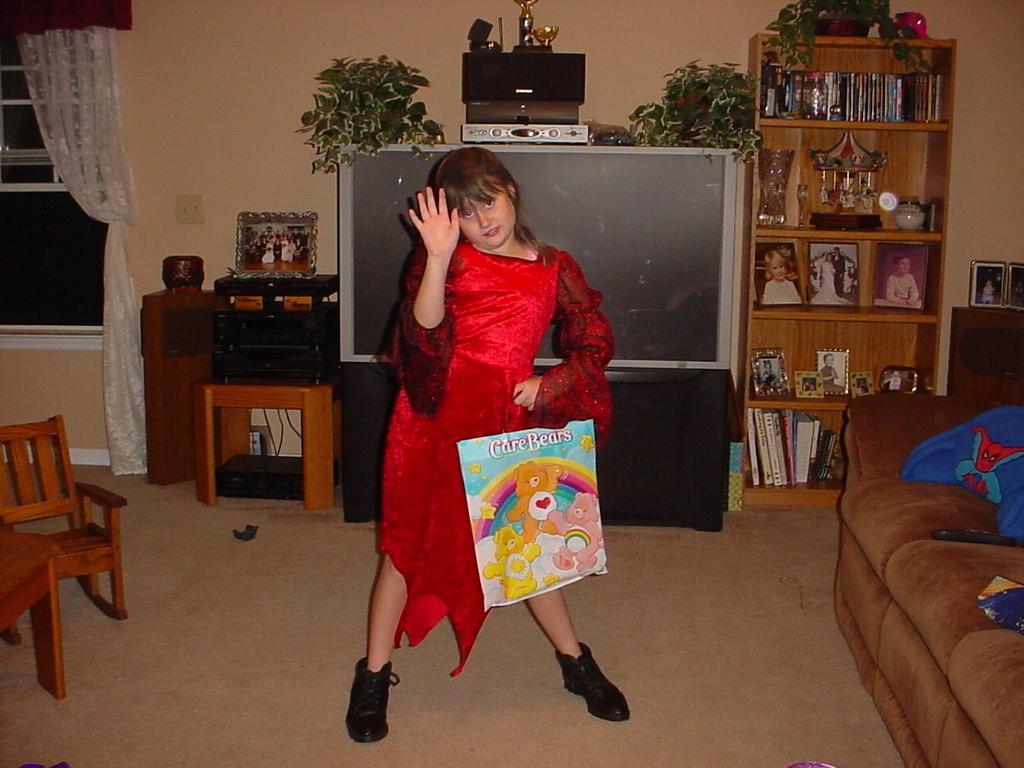How would you summarize this image in a sentence or two? In this image there is a person wearing red color dress standing on the floor and at the right side of the image there are books,photos in the shelves and at the left side of the image there is a chair and window. 